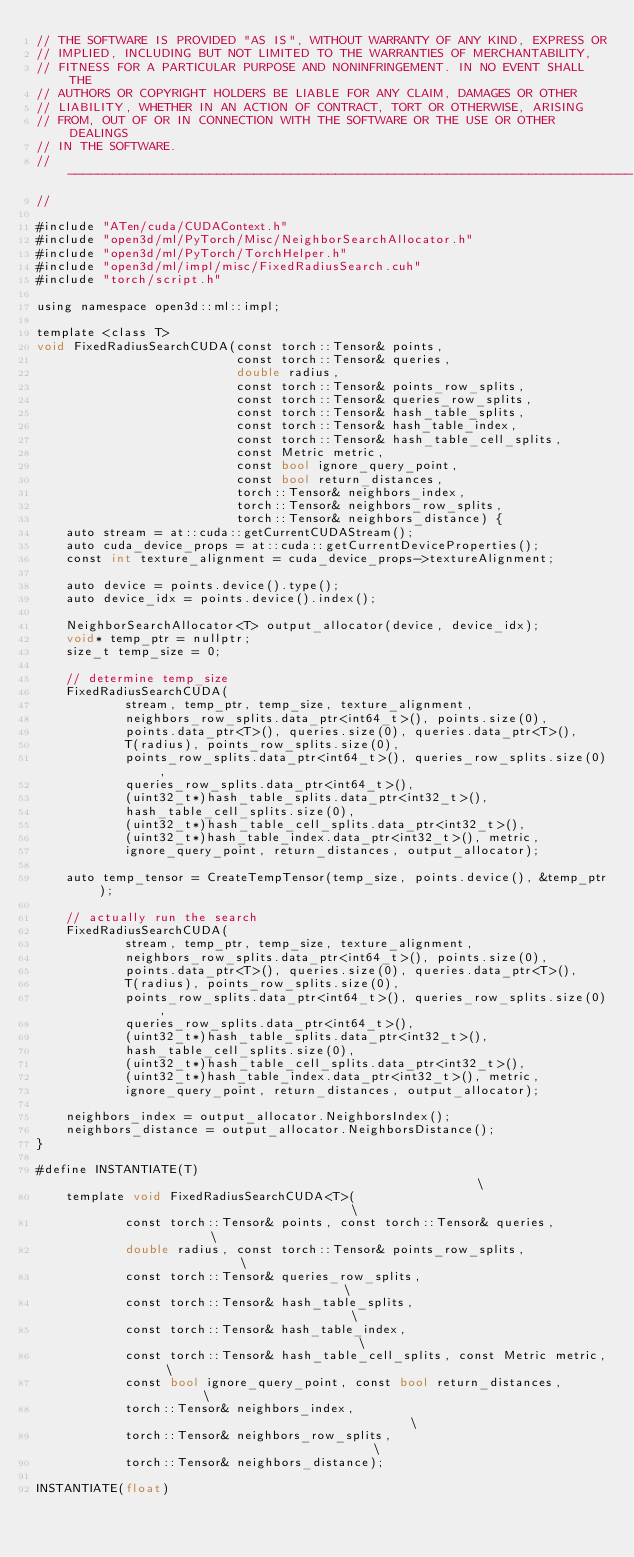<code> <loc_0><loc_0><loc_500><loc_500><_Cuda_>// THE SOFTWARE IS PROVIDED "AS IS", WITHOUT WARRANTY OF ANY KIND, EXPRESS OR
// IMPLIED, INCLUDING BUT NOT LIMITED TO THE WARRANTIES OF MERCHANTABILITY,
// FITNESS FOR A PARTICULAR PURPOSE AND NONINFRINGEMENT. IN NO EVENT SHALL THE
// AUTHORS OR COPYRIGHT HOLDERS BE LIABLE FOR ANY CLAIM, DAMAGES OR OTHER
// LIABILITY, WHETHER IN AN ACTION OF CONTRACT, TORT OR OTHERWISE, ARISING
// FROM, OUT OF OR IN CONNECTION WITH THE SOFTWARE OR THE USE OR OTHER DEALINGS
// IN THE SOFTWARE.
// ----------------------------------------------------------------------------
//

#include "ATen/cuda/CUDAContext.h"
#include "open3d/ml/PyTorch/Misc/NeighborSearchAllocator.h"
#include "open3d/ml/PyTorch/TorchHelper.h"
#include "open3d/ml/impl/misc/FixedRadiusSearch.cuh"
#include "torch/script.h"

using namespace open3d::ml::impl;

template <class T>
void FixedRadiusSearchCUDA(const torch::Tensor& points,
                           const torch::Tensor& queries,
                           double radius,
                           const torch::Tensor& points_row_splits,
                           const torch::Tensor& queries_row_splits,
                           const torch::Tensor& hash_table_splits,
                           const torch::Tensor& hash_table_index,
                           const torch::Tensor& hash_table_cell_splits,
                           const Metric metric,
                           const bool ignore_query_point,
                           const bool return_distances,
                           torch::Tensor& neighbors_index,
                           torch::Tensor& neighbors_row_splits,
                           torch::Tensor& neighbors_distance) {
    auto stream = at::cuda::getCurrentCUDAStream();
    auto cuda_device_props = at::cuda::getCurrentDeviceProperties();
    const int texture_alignment = cuda_device_props->textureAlignment;

    auto device = points.device().type();
    auto device_idx = points.device().index();

    NeighborSearchAllocator<T> output_allocator(device, device_idx);
    void* temp_ptr = nullptr;
    size_t temp_size = 0;

    // determine temp_size
    FixedRadiusSearchCUDA(
            stream, temp_ptr, temp_size, texture_alignment,
            neighbors_row_splits.data_ptr<int64_t>(), points.size(0),
            points.data_ptr<T>(), queries.size(0), queries.data_ptr<T>(),
            T(radius), points_row_splits.size(0),
            points_row_splits.data_ptr<int64_t>(), queries_row_splits.size(0),
            queries_row_splits.data_ptr<int64_t>(),
            (uint32_t*)hash_table_splits.data_ptr<int32_t>(),
            hash_table_cell_splits.size(0),
            (uint32_t*)hash_table_cell_splits.data_ptr<int32_t>(),
            (uint32_t*)hash_table_index.data_ptr<int32_t>(), metric,
            ignore_query_point, return_distances, output_allocator);

    auto temp_tensor = CreateTempTensor(temp_size, points.device(), &temp_ptr);

    // actually run the search
    FixedRadiusSearchCUDA(
            stream, temp_ptr, temp_size, texture_alignment,
            neighbors_row_splits.data_ptr<int64_t>(), points.size(0),
            points.data_ptr<T>(), queries.size(0), queries.data_ptr<T>(),
            T(radius), points_row_splits.size(0),
            points_row_splits.data_ptr<int64_t>(), queries_row_splits.size(0),
            queries_row_splits.data_ptr<int64_t>(),
            (uint32_t*)hash_table_splits.data_ptr<int32_t>(),
            hash_table_cell_splits.size(0),
            (uint32_t*)hash_table_cell_splits.data_ptr<int32_t>(),
            (uint32_t*)hash_table_index.data_ptr<int32_t>(), metric,
            ignore_query_point, return_distances, output_allocator);

    neighbors_index = output_allocator.NeighborsIndex();
    neighbors_distance = output_allocator.NeighborsDistance();
}

#define INSTANTIATE(T)                                                        \
    template void FixedRadiusSearchCUDA<T>(                                   \
            const torch::Tensor& points, const torch::Tensor& queries,        \
            double radius, const torch::Tensor& points_row_splits,            \
            const torch::Tensor& queries_row_splits,                          \
            const torch::Tensor& hash_table_splits,                           \
            const torch::Tensor& hash_table_index,                            \
            const torch::Tensor& hash_table_cell_splits, const Metric metric, \
            const bool ignore_query_point, const bool return_distances,       \
            torch::Tensor& neighbors_index,                                   \
            torch::Tensor& neighbors_row_splits,                              \
            torch::Tensor& neighbors_distance);

INSTANTIATE(float)
</code> 